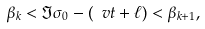Convert formula to latex. <formula><loc_0><loc_0><loc_500><loc_500>\beta _ { k } < \Im \sigma _ { 0 } - ( \ v t + \ell ) < \beta _ { k + 1 } ,</formula> 